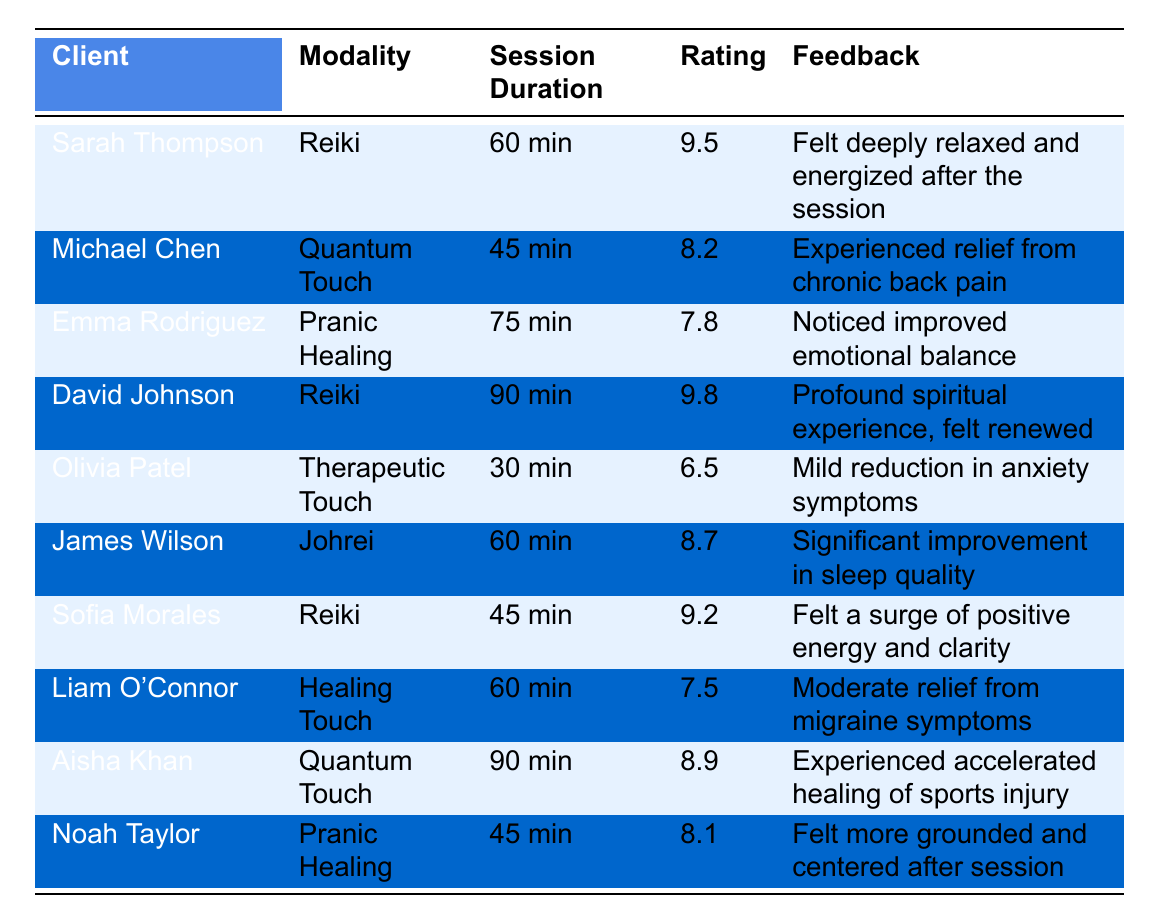What is the highest rating given for a modality? Looking at the Ratings column, the highest value is 9.8, which belongs to David Johnson who received a Reiki session.
Answer: 9.8 Which modality received the lowest rating? The lowest rating in the table is 6.5, given to Olivia Patel for Therapeutic Touch.
Answer: Therapeutic Touch How many clients reported a rating of 9 or higher? Checking the Ratings column, the ratings of 9 or higher are given by Sarah Thompson (9.5), David Johnson (9.8), and Sofia Morales (9.2), totaling three clients.
Answer: 3 What is the average rating for the Reiki modality? The ratings for Reiki are 9.5 (Sarah), 9.8 (David), and 9.2 (Sofia). Summing these gives 9.5 + 9.8 + 9.2 = 28.5. Dividing by the number of sessions (3), the average is 28.5 / 3 = 9.5.
Answer: 9.5 Did any client mention improvement in sleep quality? Yes, James Wilson reported a significant improvement in sleep quality after a session of Johrei.
Answer: Yes Which modality had the longest session duration? The table shows the session durations, with Emma Rodriguez's Pranic Healing session lasting 75 minutes, which is the longest duration listed.
Answer: Pranic Healing How many clients used Quantum Touch, and what are their ratings? There are two clients who used Quantum Touch: Michael Chen rated it 8.2 and Aisha Khan rated it 8.9.
Answer: 2 clients: 8.2 and 8.9 What is the difference in ratings between the highest and lowest-rated modalities? The highest rating is 9.8 (Reiki) and the lowest is 6.5 (Therapeutic Touch). The difference is 9.8 - 6.5 = 3.3.
Answer: 3.3 Does any client mention feeling energized or renewed? Yes, Sarah Thompson felt deeply relaxed and energized after her Reiki session, and David Johnson felt renewed after his Reiki session as well.
Answer: Yes Which client had a session lasting less than 60 minutes, and what was their rating? Olivia Patel had a session of 30 minutes for Therapeutic Touch, and her rating was 6.5.
Answer: Olivia Patel, 6.5 